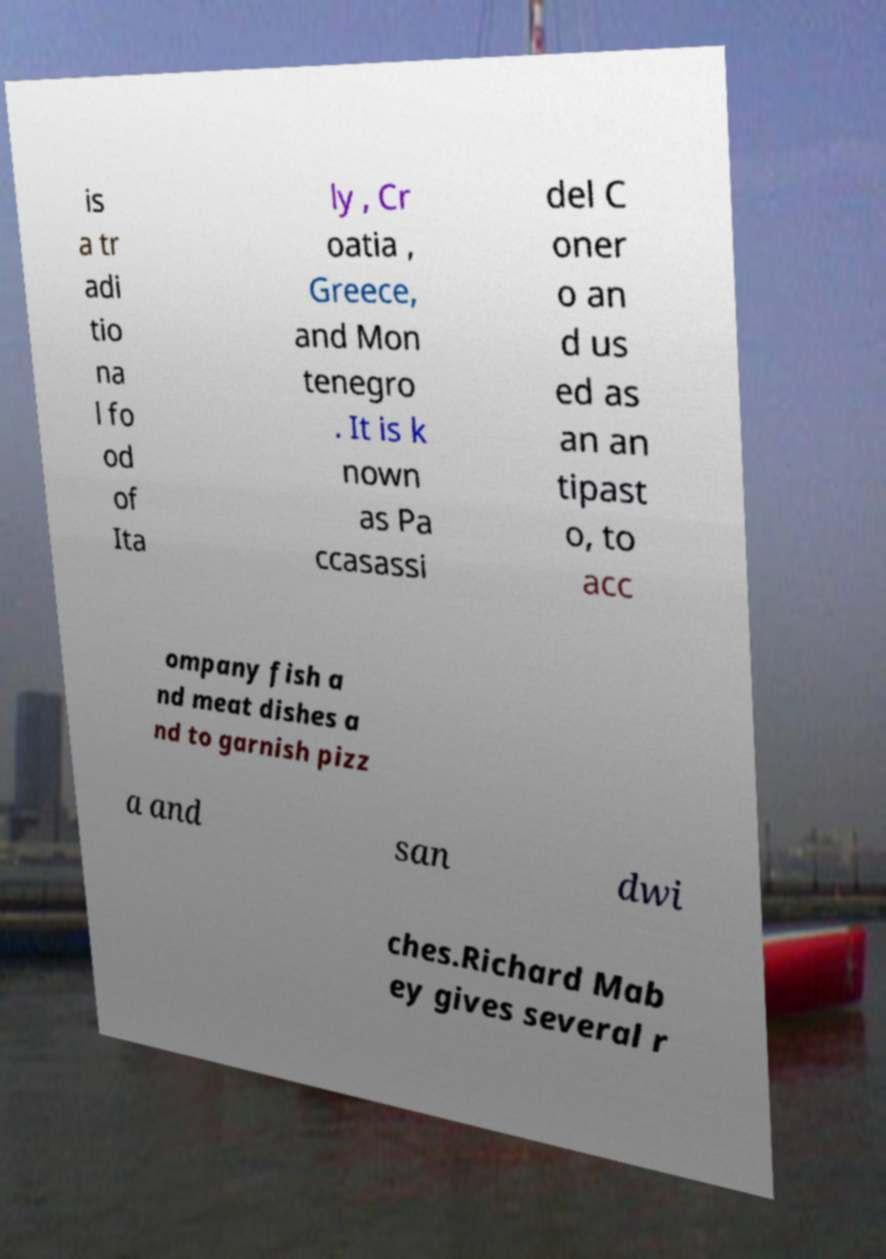There's text embedded in this image that I need extracted. Can you transcribe it verbatim? is a tr adi tio na l fo od of Ita ly , Cr oatia , Greece, and Mon tenegro . It is k nown as Pa ccasassi del C oner o an d us ed as an an tipast o, to acc ompany fish a nd meat dishes a nd to garnish pizz a and san dwi ches.Richard Mab ey gives several r 